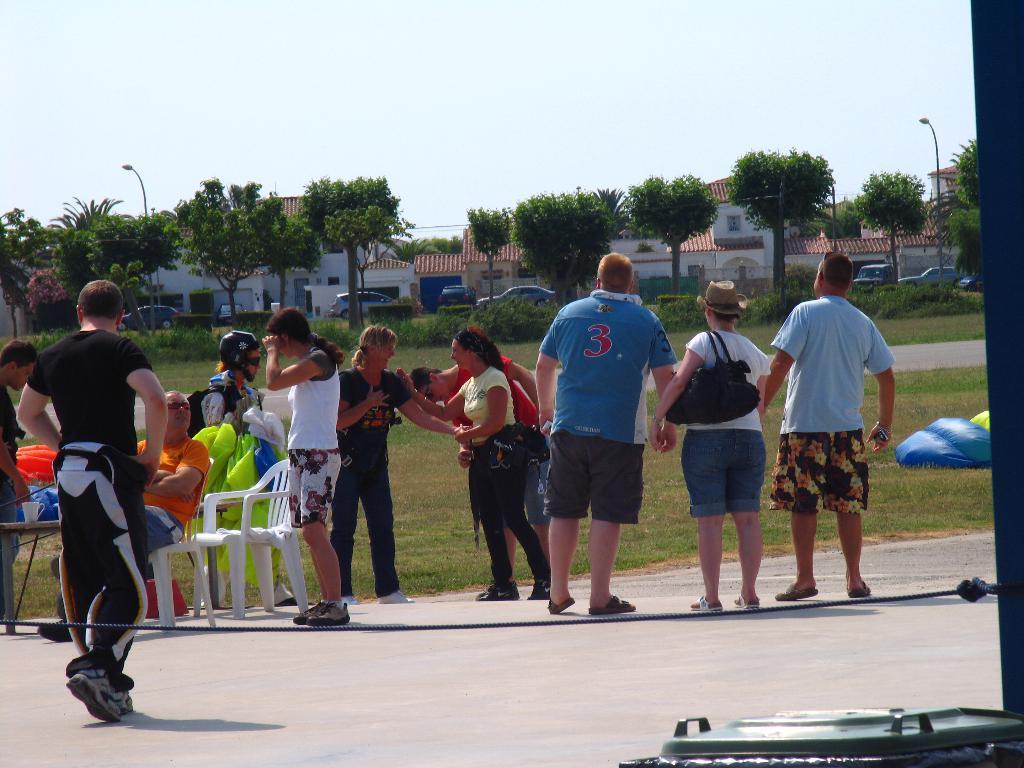Please provide a concise description of this image. In this picture I can see group of people standing, there are chairs, there are some objects on the table, there is grass, plants, there are poles, lights, vehicles, there are houses, trees, and in the background there is the sky. 